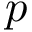<formula> <loc_0><loc_0><loc_500><loc_500>p</formula> 